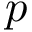<formula> <loc_0><loc_0><loc_500><loc_500>p</formula> 